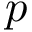<formula> <loc_0><loc_0><loc_500><loc_500>p</formula> 